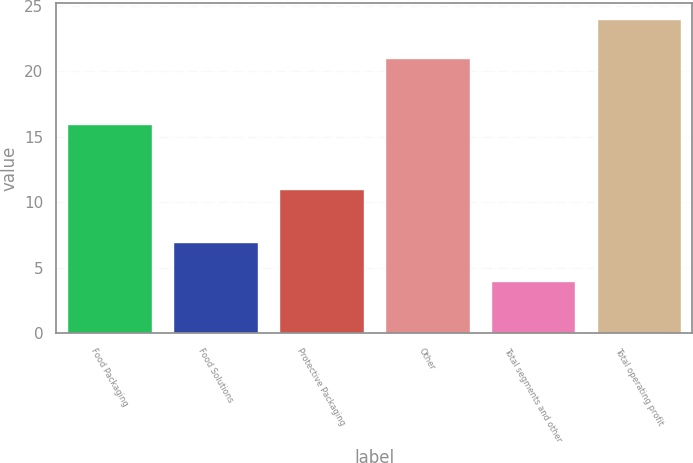<chart> <loc_0><loc_0><loc_500><loc_500><bar_chart><fcel>Food Packaging<fcel>Food Solutions<fcel>Protective Packaging<fcel>Other<fcel>Total segments and other<fcel>Total operating profit<nl><fcel>16<fcel>7<fcel>11<fcel>21<fcel>4<fcel>24<nl></chart> 